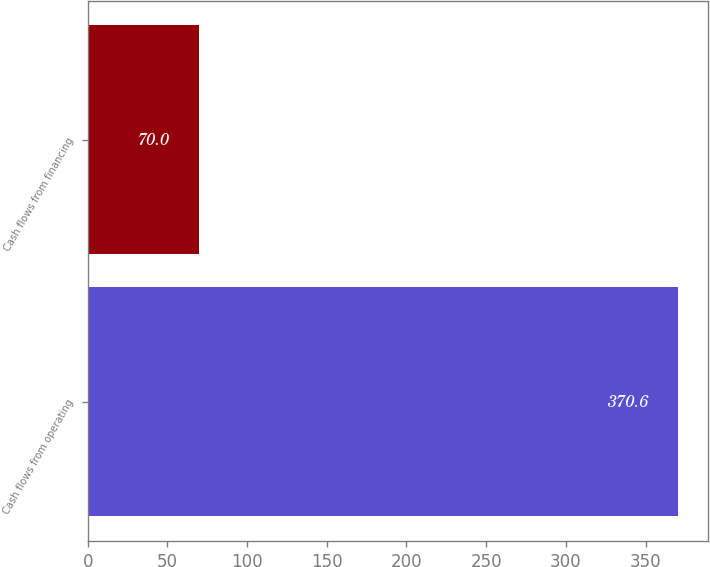Convert chart to OTSL. <chart><loc_0><loc_0><loc_500><loc_500><bar_chart><fcel>Cash flows from operating<fcel>Cash flows from financing<nl><fcel>370.6<fcel>70<nl></chart> 